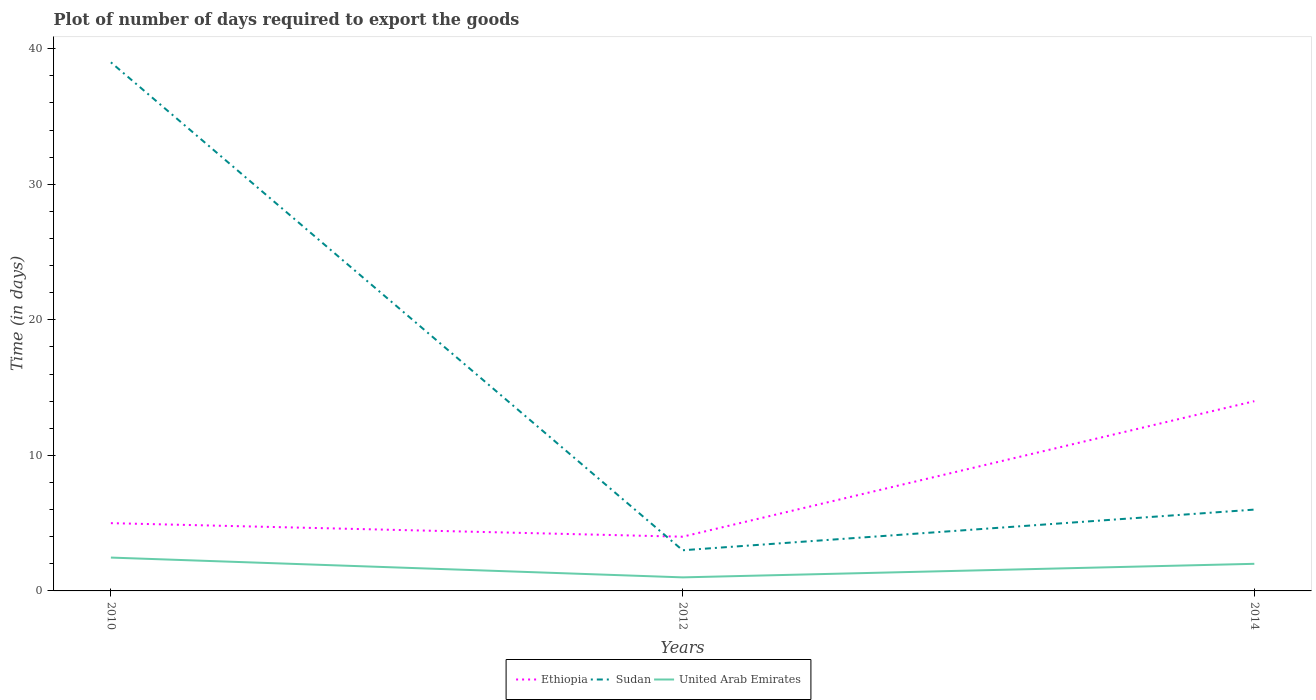How many different coloured lines are there?
Your answer should be compact. 3. Does the line corresponding to United Arab Emirates intersect with the line corresponding to Sudan?
Give a very brief answer. No. Is the number of lines equal to the number of legend labels?
Your answer should be very brief. Yes. Across all years, what is the maximum time required to export goods in United Arab Emirates?
Provide a succinct answer. 1. In which year was the time required to export goods in Ethiopia maximum?
Make the answer very short. 2012. What is the total time required to export goods in Sudan in the graph?
Make the answer very short. 33. What is the difference between the highest and the second highest time required to export goods in United Arab Emirates?
Offer a very short reply. 1.46. Are the values on the major ticks of Y-axis written in scientific E-notation?
Your answer should be very brief. No. Does the graph contain grids?
Give a very brief answer. No. Where does the legend appear in the graph?
Your answer should be very brief. Bottom center. How are the legend labels stacked?
Keep it short and to the point. Horizontal. What is the title of the graph?
Ensure brevity in your answer.  Plot of number of days required to export the goods. Does "Somalia" appear as one of the legend labels in the graph?
Your answer should be compact. No. What is the label or title of the Y-axis?
Provide a succinct answer. Time (in days). What is the Time (in days) in Ethiopia in 2010?
Make the answer very short. 5. What is the Time (in days) in United Arab Emirates in 2010?
Make the answer very short. 2.46. What is the Time (in days) of Sudan in 2012?
Keep it short and to the point. 3. Across all years, what is the maximum Time (in days) in Ethiopia?
Your answer should be very brief. 14. Across all years, what is the maximum Time (in days) in Sudan?
Make the answer very short. 39. Across all years, what is the maximum Time (in days) in United Arab Emirates?
Your response must be concise. 2.46. Across all years, what is the minimum Time (in days) of Sudan?
Keep it short and to the point. 3. Across all years, what is the minimum Time (in days) of United Arab Emirates?
Keep it short and to the point. 1. What is the total Time (in days) in Ethiopia in the graph?
Give a very brief answer. 23. What is the total Time (in days) of United Arab Emirates in the graph?
Your response must be concise. 5.46. What is the difference between the Time (in days) of United Arab Emirates in 2010 and that in 2012?
Your answer should be very brief. 1.46. What is the difference between the Time (in days) in Ethiopia in 2010 and that in 2014?
Provide a short and direct response. -9. What is the difference between the Time (in days) of United Arab Emirates in 2010 and that in 2014?
Offer a very short reply. 0.46. What is the difference between the Time (in days) in Ethiopia in 2010 and the Time (in days) in United Arab Emirates in 2012?
Your response must be concise. 4. What is the difference between the Time (in days) in Sudan in 2010 and the Time (in days) in United Arab Emirates in 2012?
Keep it short and to the point. 38. What is the difference between the Time (in days) in Ethiopia in 2010 and the Time (in days) in United Arab Emirates in 2014?
Offer a very short reply. 3. What is the difference between the Time (in days) in Sudan in 2010 and the Time (in days) in United Arab Emirates in 2014?
Keep it short and to the point. 37. What is the average Time (in days) in Ethiopia per year?
Provide a succinct answer. 7.67. What is the average Time (in days) in United Arab Emirates per year?
Provide a short and direct response. 1.82. In the year 2010, what is the difference between the Time (in days) in Ethiopia and Time (in days) in Sudan?
Your answer should be very brief. -34. In the year 2010, what is the difference between the Time (in days) in Ethiopia and Time (in days) in United Arab Emirates?
Offer a terse response. 2.54. In the year 2010, what is the difference between the Time (in days) in Sudan and Time (in days) in United Arab Emirates?
Keep it short and to the point. 36.54. In the year 2012, what is the difference between the Time (in days) of Ethiopia and Time (in days) of United Arab Emirates?
Provide a short and direct response. 3. In the year 2012, what is the difference between the Time (in days) of Sudan and Time (in days) of United Arab Emirates?
Your response must be concise. 2. In the year 2014, what is the difference between the Time (in days) of Ethiopia and Time (in days) of Sudan?
Your answer should be compact. 8. What is the ratio of the Time (in days) of Ethiopia in 2010 to that in 2012?
Your answer should be very brief. 1.25. What is the ratio of the Time (in days) of Sudan in 2010 to that in 2012?
Your answer should be very brief. 13. What is the ratio of the Time (in days) of United Arab Emirates in 2010 to that in 2012?
Give a very brief answer. 2.46. What is the ratio of the Time (in days) in Ethiopia in 2010 to that in 2014?
Offer a terse response. 0.36. What is the ratio of the Time (in days) of United Arab Emirates in 2010 to that in 2014?
Your response must be concise. 1.23. What is the ratio of the Time (in days) of Ethiopia in 2012 to that in 2014?
Your response must be concise. 0.29. What is the ratio of the Time (in days) of Sudan in 2012 to that in 2014?
Offer a very short reply. 0.5. What is the ratio of the Time (in days) of United Arab Emirates in 2012 to that in 2014?
Offer a very short reply. 0.5. What is the difference between the highest and the second highest Time (in days) of Sudan?
Your response must be concise. 33. What is the difference between the highest and the second highest Time (in days) of United Arab Emirates?
Offer a very short reply. 0.46. What is the difference between the highest and the lowest Time (in days) of Ethiopia?
Keep it short and to the point. 10. What is the difference between the highest and the lowest Time (in days) in Sudan?
Your answer should be very brief. 36. What is the difference between the highest and the lowest Time (in days) of United Arab Emirates?
Your answer should be very brief. 1.46. 